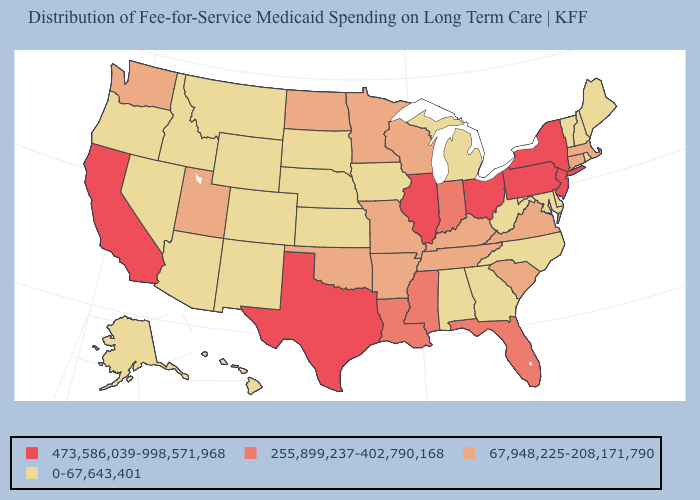Does California have the highest value in the West?
Keep it brief. Yes. Is the legend a continuous bar?
Short answer required. No. What is the value of Indiana?
Be succinct. 255,899,237-402,790,168. What is the lowest value in the USA?
Be succinct. 0-67,643,401. Does the map have missing data?
Be succinct. No. What is the value of Vermont?
Write a very short answer. 0-67,643,401. Name the states that have a value in the range 0-67,643,401?
Concise answer only. Alabama, Alaska, Arizona, Colorado, Delaware, Georgia, Hawaii, Idaho, Iowa, Kansas, Maine, Maryland, Michigan, Montana, Nebraska, Nevada, New Hampshire, New Mexico, North Carolina, Oregon, Rhode Island, South Dakota, Vermont, West Virginia, Wyoming. How many symbols are there in the legend?
Answer briefly. 4. Does Alabama have the lowest value in the USA?
Write a very short answer. Yes. Which states have the highest value in the USA?
Short answer required. California, Illinois, New Jersey, New York, Ohio, Pennsylvania, Texas. Which states hav the highest value in the South?
Be succinct. Texas. Which states have the lowest value in the Northeast?
Give a very brief answer. Maine, New Hampshire, Rhode Island, Vermont. Name the states that have a value in the range 67,948,225-208,171,790?
Keep it brief. Arkansas, Connecticut, Kentucky, Massachusetts, Minnesota, Missouri, North Dakota, Oklahoma, South Carolina, Tennessee, Utah, Virginia, Washington, Wisconsin. Does Kansas have the same value as Utah?
Answer briefly. No. 